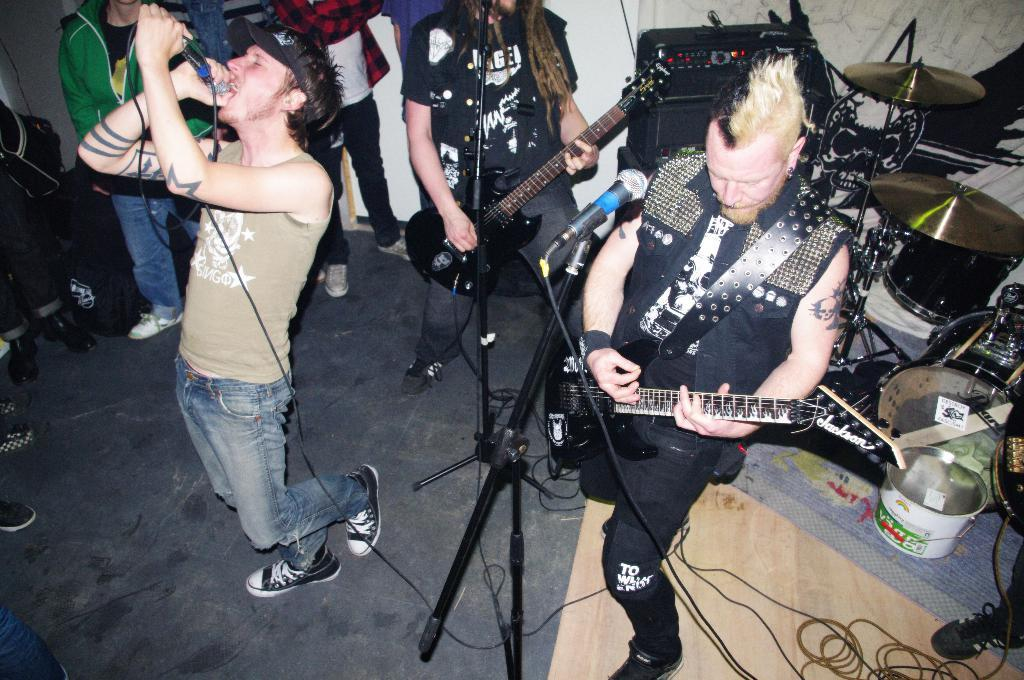How many people are in the image? There is a group of people in the image. What is one person in the group doing? One person is holding a microphone. What is the person with the microphone doing? The person with the microphone is singing. What can be seen in the background of the image? There are musical instruments in the background. What type of stove is visible in the image? There is no stove present in the image. What mathematical operation is being performed by the person with the microphone? The person with the microphone is singing, not performing a mathematical operation. 